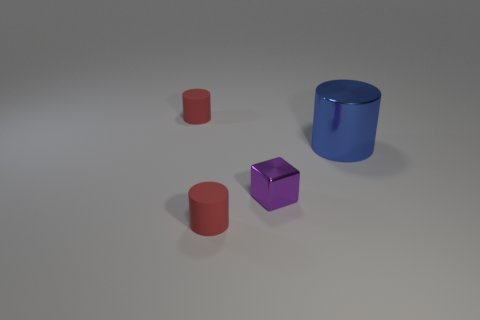Is there anything else that is the same size as the blue metal cylinder?
Provide a short and direct response. No. Is the shape of the metal thing that is to the right of the cube the same as  the purple thing?
Provide a succinct answer. No. What number of things are on the left side of the large cylinder and behind the small purple object?
Offer a very short reply. 1. What shape is the small red thing that is behind the large blue cylinder?
Your response must be concise. Cylinder. How many blue objects are the same material as the blue cylinder?
Your answer should be compact. 0. Do the blue metallic thing and the metallic thing to the left of the large blue thing have the same shape?
Provide a short and direct response. No. There is a small rubber object in front of the rubber object behind the big blue shiny thing; are there any blocks behind it?
Offer a terse response. Yes. What size is the shiny object that is in front of the large metallic object?
Provide a short and direct response. Small. Does the small purple thing have the same shape as the large thing?
Make the answer very short. No. How many objects are either blue balls or cylinders left of the purple cube?
Your answer should be very brief. 2. 